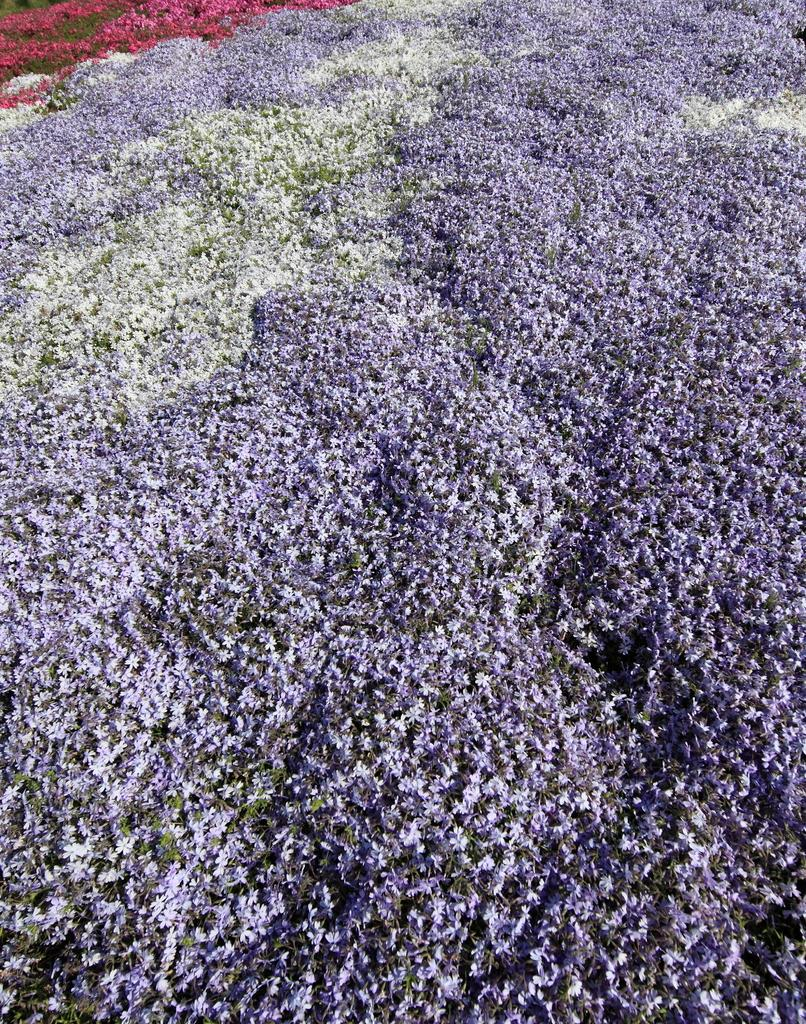What type of plants can be seen in the image? There are flowers in the image. What colors are the flowers in the image? The flowers are white, red, and purple in color. What type of crib can be seen in the image? There is no crib present in the image; it features flowers of different colors. 